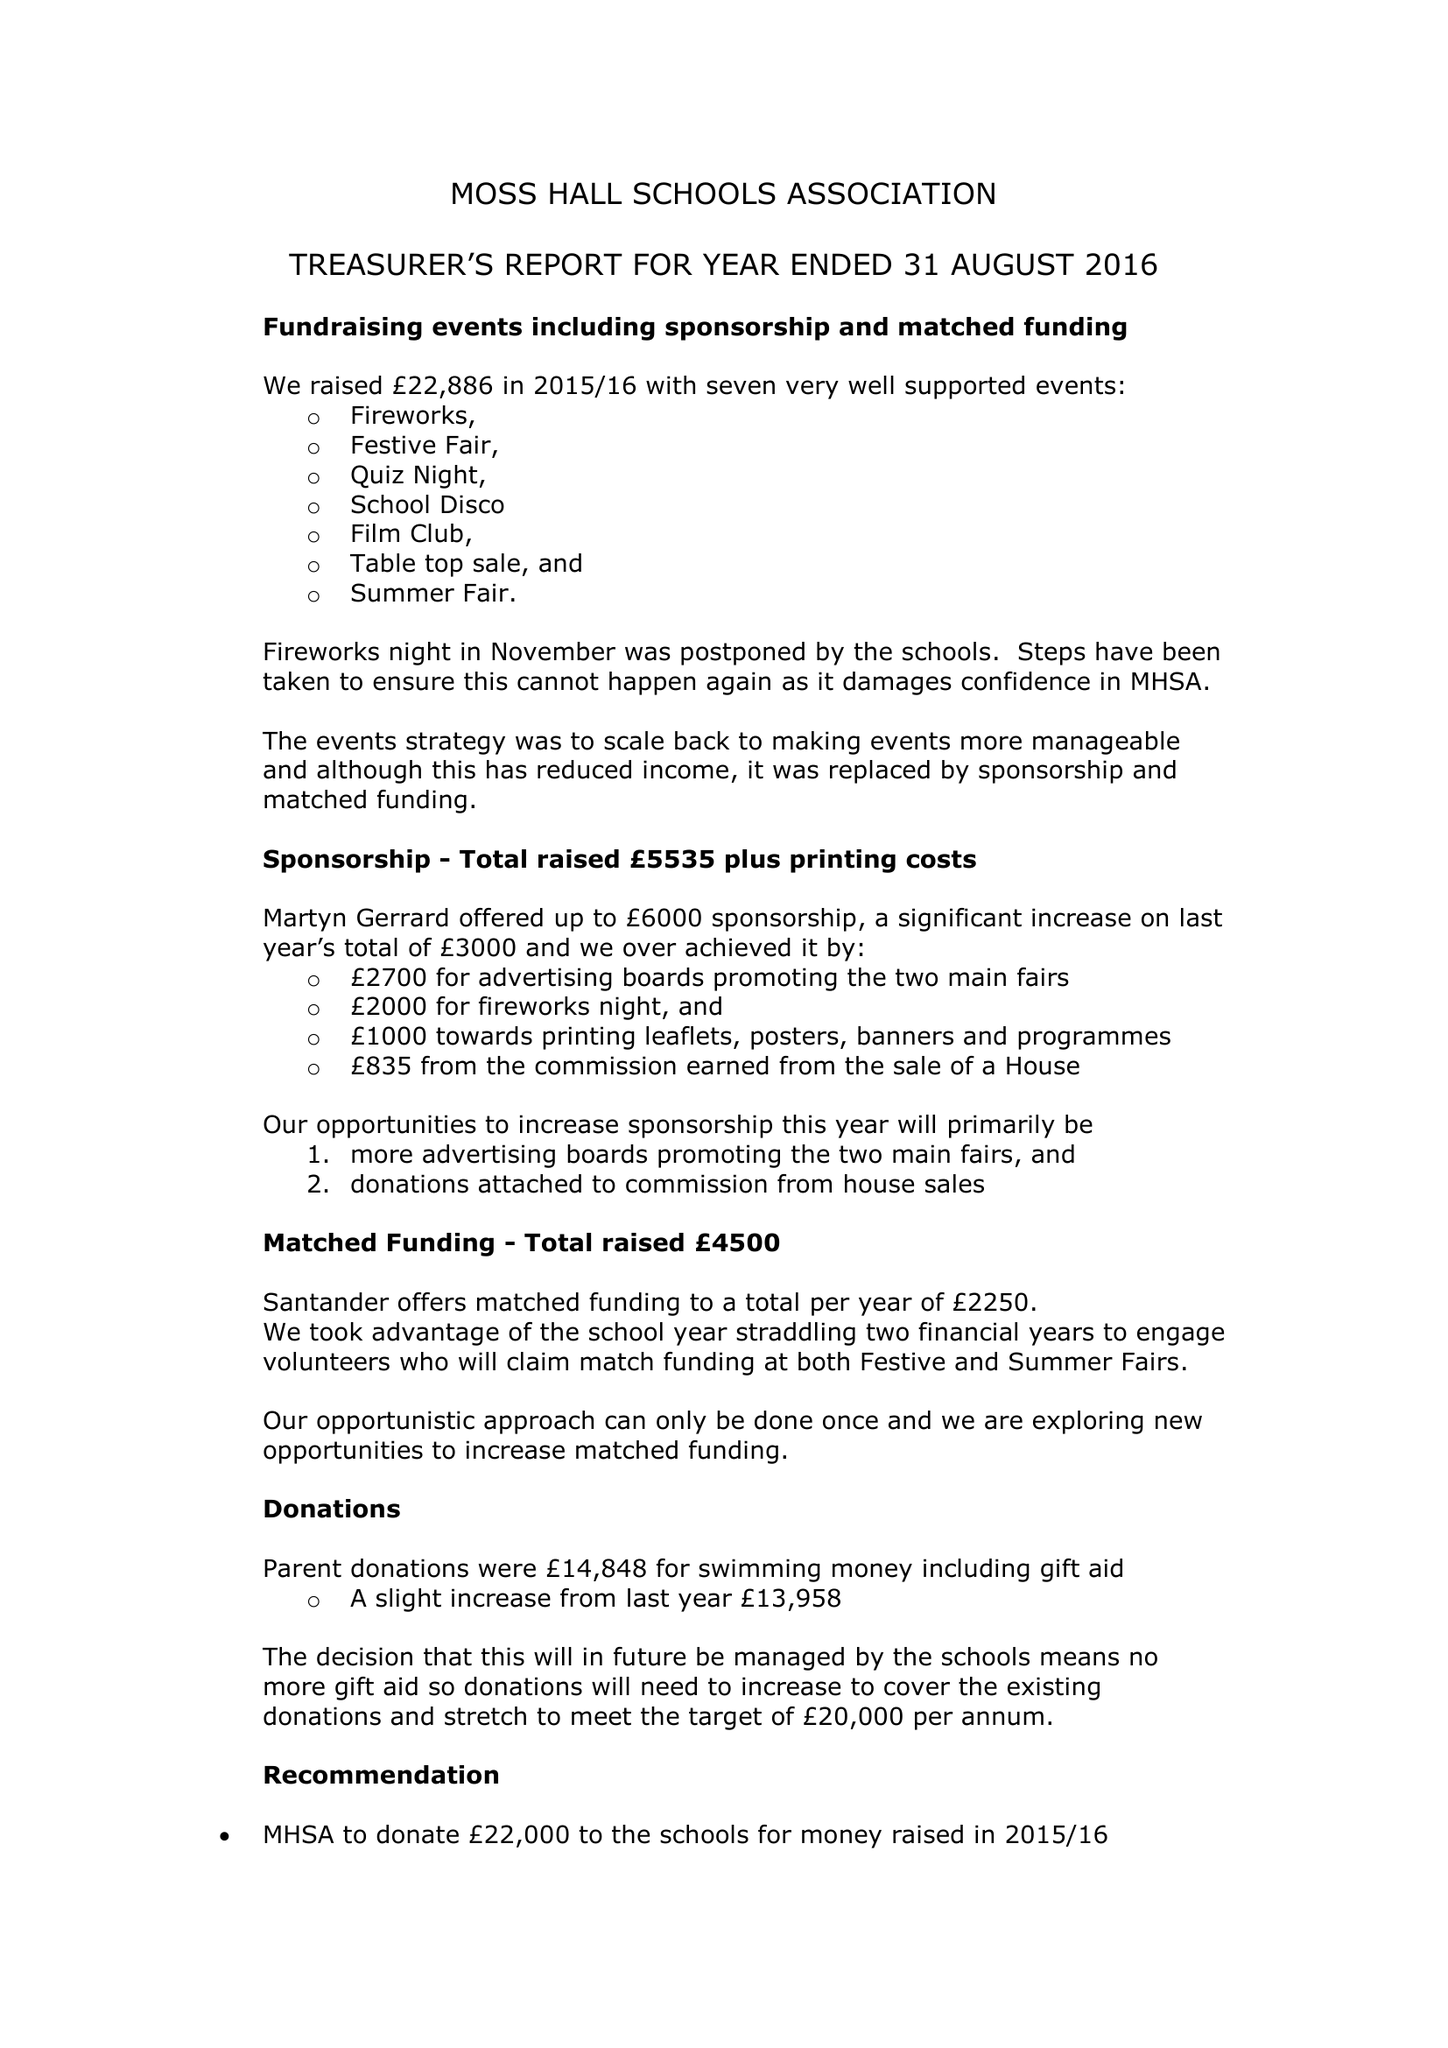What is the value for the charity_name?
Answer the question using a single word or phrase. Moss Hall Schools Association 